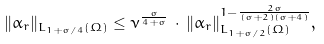Convert formula to latex. <formula><loc_0><loc_0><loc_500><loc_500>\| \alpha _ { r } \| _ { L _ { 1 + \sigma / 4 } ( \Omega ) } \leq \nu ^ { \frac { \sigma } { 4 + \sigma } } \, \cdot \, \| \alpha _ { r } \| _ { L _ { 1 + \sigma / 2 } ( \Omega ) } ^ { 1 - \frac { 2 \sigma } { ( \sigma + 2 ) ( \sigma + 4 ) } } ,</formula> 